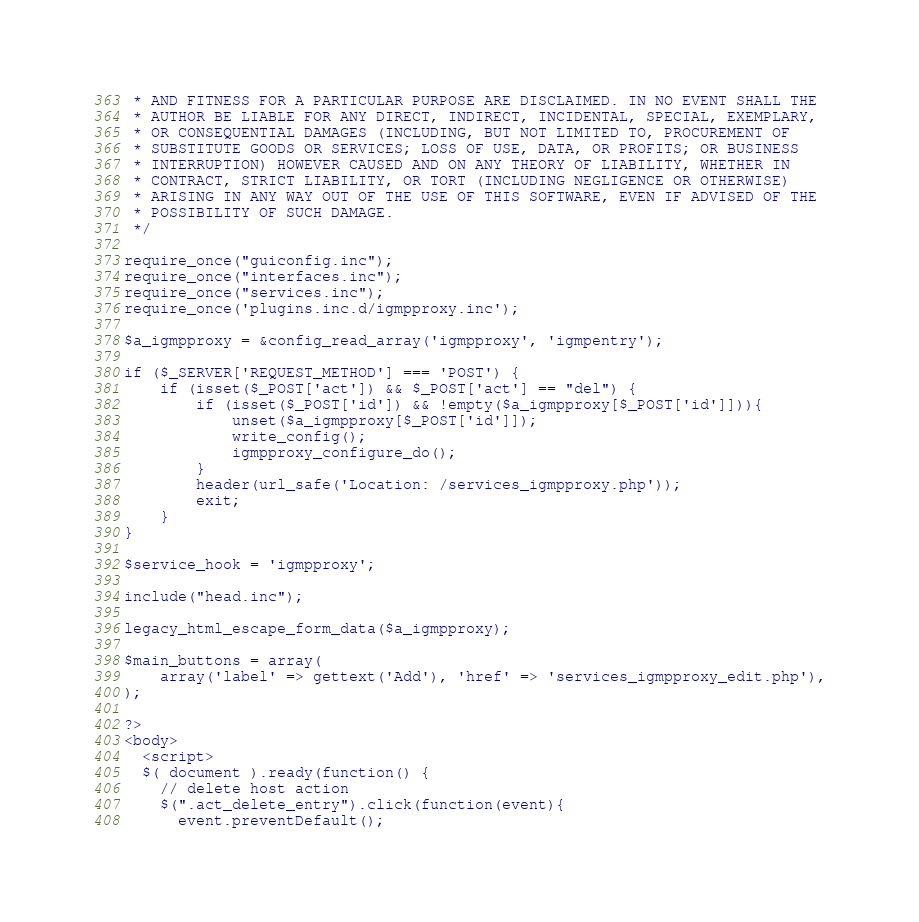Convert code to text. <code><loc_0><loc_0><loc_500><loc_500><_PHP_> * AND FITNESS FOR A PARTICULAR PURPOSE ARE DISCLAIMED. IN NO EVENT SHALL THE
 * AUTHOR BE LIABLE FOR ANY DIRECT, INDIRECT, INCIDENTAL, SPECIAL, EXEMPLARY,
 * OR CONSEQUENTIAL DAMAGES (INCLUDING, BUT NOT LIMITED TO, PROCUREMENT OF
 * SUBSTITUTE GOODS OR SERVICES; LOSS OF USE, DATA, OR PROFITS; OR BUSINESS
 * INTERRUPTION) HOWEVER CAUSED AND ON ANY THEORY OF LIABILITY, WHETHER IN
 * CONTRACT, STRICT LIABILITY, OR TORT (INCLUDING NEGLIGENCE OR OTHERWISE)
 * ARISING IN ANY WAY OUT OF THE USE OF THIS SOFTWARE, EVEN IF ADVISED OF THE
 * POSSIBILITY OF SUCH DAMAGE.
 */

require_once("guiconfig.inc");
require_once("interfaces.inc");
require_once("services.inc");
require_once('plugins.inc.d/igmpproxy.inc');

$a_igmpproxy = &config_read_array('igmpproxy', 'igmpentry');

if ($_SERVER['REQUEST_METHOD'] === 'POST') {
    if (isset($_POST['act']) && $_POST['act'] == "del") {
        if (isset($_POST['id']) && !empty($a_igmpproxy[$_POST['id']])){
            unset($a_igmpproxy[$_POST['id']]);
            write_config();
            igmpproxy_configure_do();
        }
        header(url_safe('Location: /services_igmpproxy.php'));
        exit;
    }
}

$service_hook = 'igmpproxy';

include("head.inc");

legacy_html_escape_form_data($a_igmpproxy);

$main_buttons = array(
    array('label' => gettext('Add'), 'href' => 'services_igmpproxy_edit.php'),
);

?>
<body>
  <script>
  $( document ).ready(function() {
    // delete host action
    $(".act_delete_entry").click(function(event){
      event.preventDefault();</code> 